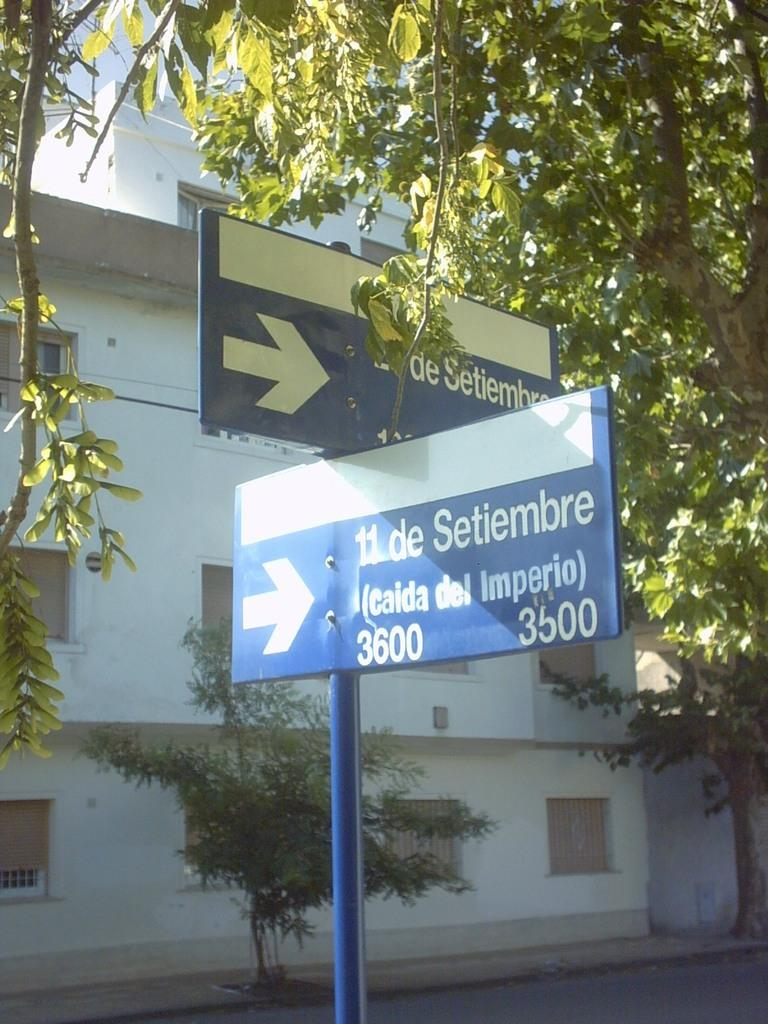What type of sign is present in the image? There is a blue direction board in the image. What natural element can be seen in the image? There is a tree visible in the image. What color is the house in the image? There is a white-colored house in the image. What type of snack is being cooked in the image? There is no snack or cooking activity present in the image. Where is the faucet located in the image? There is no faucet present in the image. 